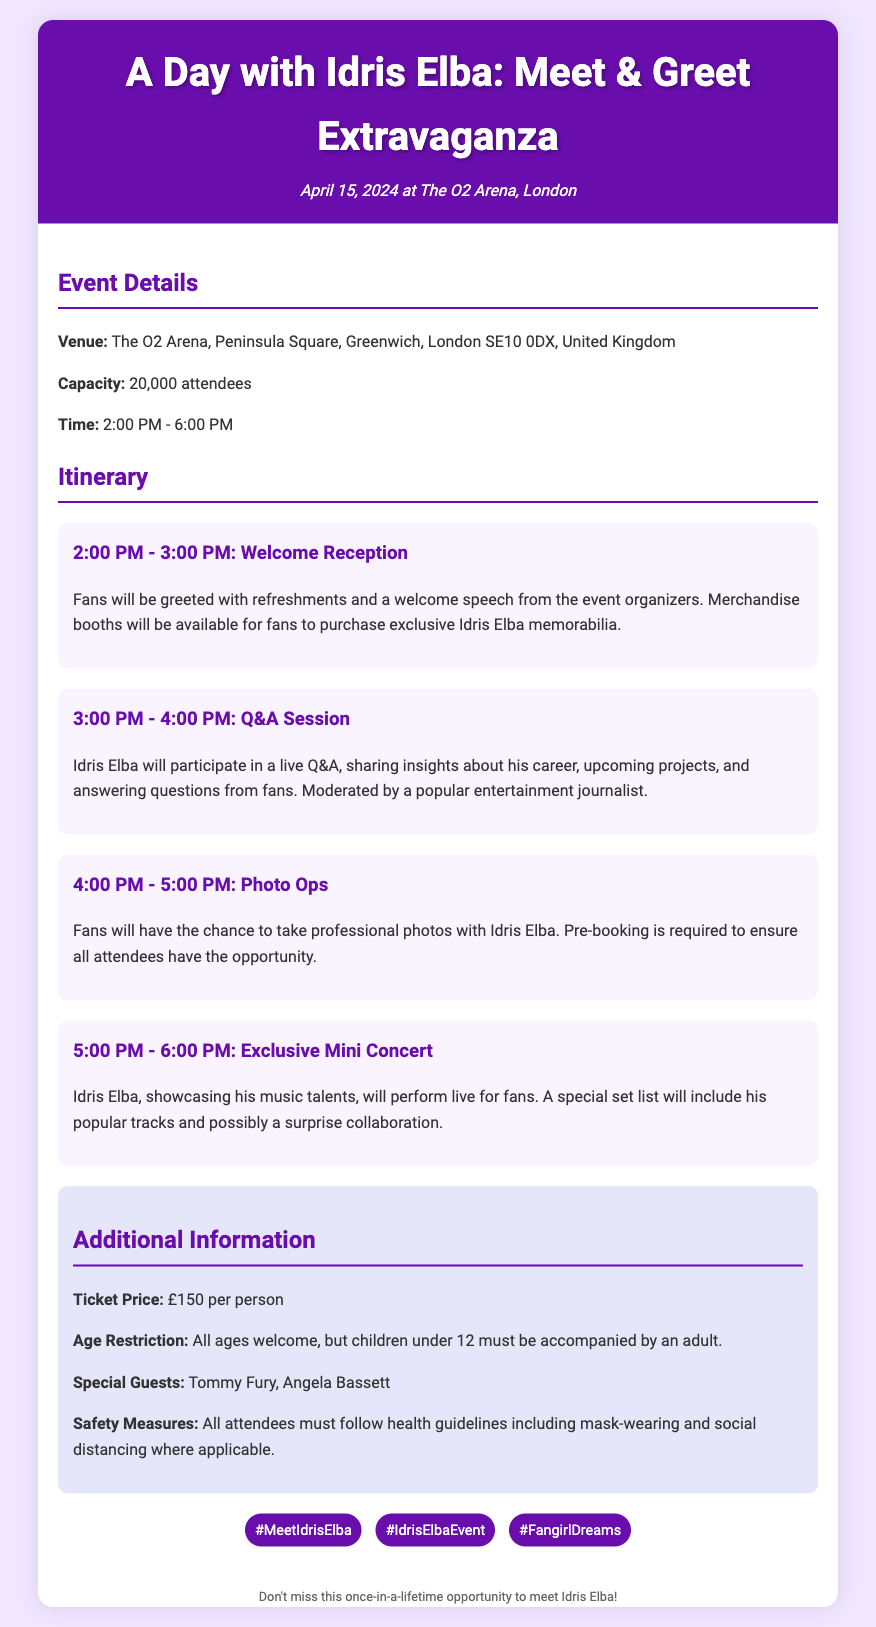What is the date of the event? The date of the event is specified in the header of the document.
Answer: April 15, 2024 What is the venue for the meet-and-greet? The document specifies the venue in the Event Details section.
Answer: The O2 Arena What time does the event start? The start time of the event is mentioned in the Event Details section.
Answer: 2:00 PM How long is the photo ops session? The duration of the photo ops session is specified in the itinerary section.
Answer: 1 hour What is the ticket price? The ticket price is listed in the Additional Information section.
Answer: £150 per person What special guests are mentioned? The special guests are listed in the Additional Information section.
Answer: Tommy Fury, Angela Bassett What activity follows the Q&A session? The schedule of activities indicates what comes after the Q&A session.
Answer: Photo Ops What health guidelines must attendees follow? The safety measures state the required health guidelines.
Answer: Mask-wearing and social distancing What is the maximum capacity of the venue? The capacity of the venue is stated in the Event Details section.
Answer: 20,000 attendees 